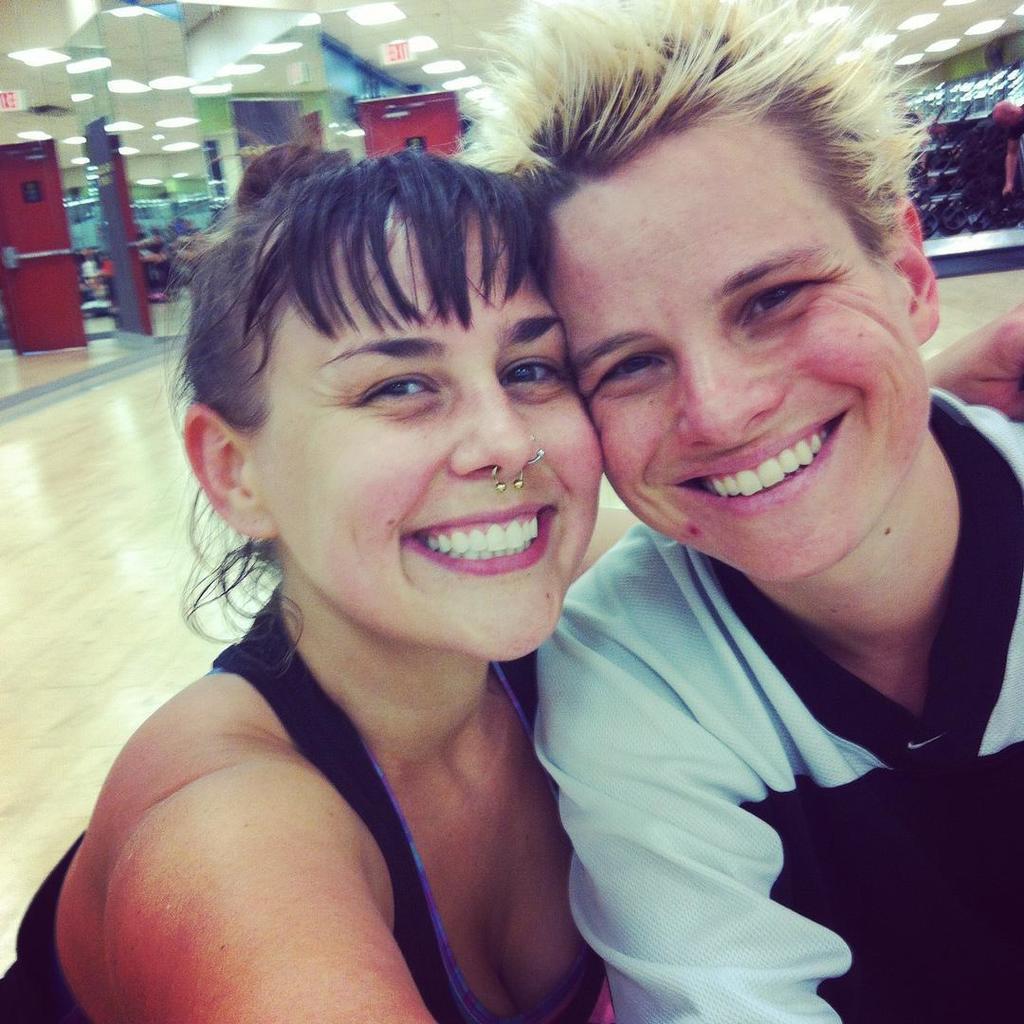How would you summarize this image in a sentence or two? In this image, we can see persons wearing clothes. There are some lights on the ceiling which is at the top of the image. 